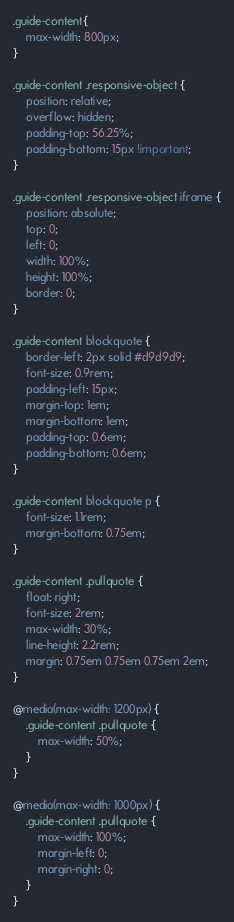<code> <loc_0><loc_0><loc_500><loc_500><_CSS_>.guide-content{
    max-width: 800px;
}

.guide-content .responsive-object {
	position: relative;
	overflow: hidden;
	padding-top: 56.25%;
	padding-bottom: 15px !important;	
}

.guide-content .responsive-object iframe {
	position: absolute;
	top: 0;
	left: 0;
	width: 100%;
	height: 100%;
	border: 0;
}

.guide-content blockquote {
	border-left: 2px solid #d9d9d9;
	font-size: 0.9rem;
	padding-left: 15px;
	margin-top: 1em;
	margin-bottom: 1em;
	padding-top: 0.6em;
	padding-bottom: 0.6em;
}

.guide-content blockquote p {
	font-size: 1.1rem;
	margin-bottom: 0.75em;
}

.guide-content .pullquote {
	float: right;
    font-size: 2rem;
    max-width: 30%;
    line-height: 2.2rem;
    margin: 0.75em 0.75em 0.75em 2em;
}

@media(max-width: 1200px) {
	.guide-content .pullquote {
	    max-width: 50%;
	}
}

@media(max-width: 1000px) {
	.guide-content .pullquote {
	    max-width: 100%;
	    margin-left: 0;
	    margin-right: 0;
	}
}</code> 